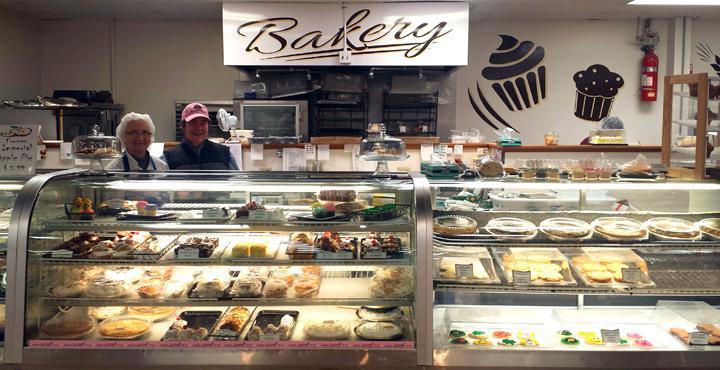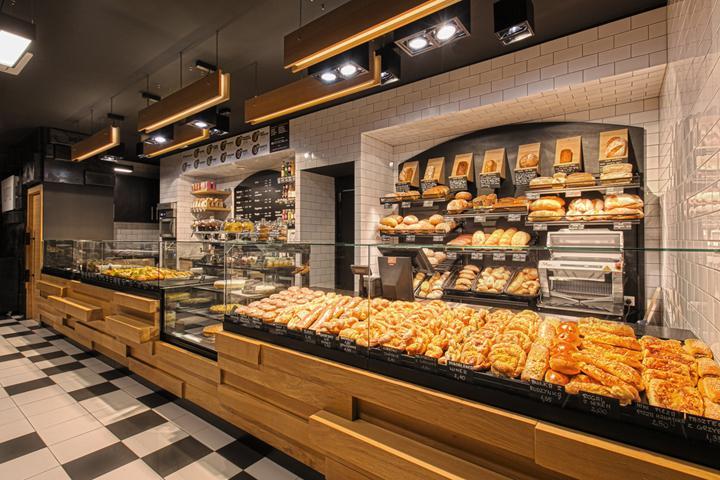The first image is the image on the left, the second image is the image on the right. Analyze the images presented: Is the assertion "Lefthand image features a bakery with a white rectangular sign with lettering only." valid? Answer yes or no. Yes. 